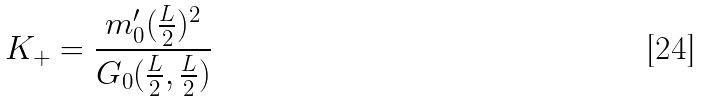Convert formula to latex. <formula><loc_0><loc_0><loc_500><loc_500>K _ { + } = \frac { m ^ { \prime } _ { 0 } ( \frac { L } { 2 } ) ^ { 2 } } { G _ { 0 } ( \frac { L } { 2 } , \frac { L } { 2 } ) }</formula> 